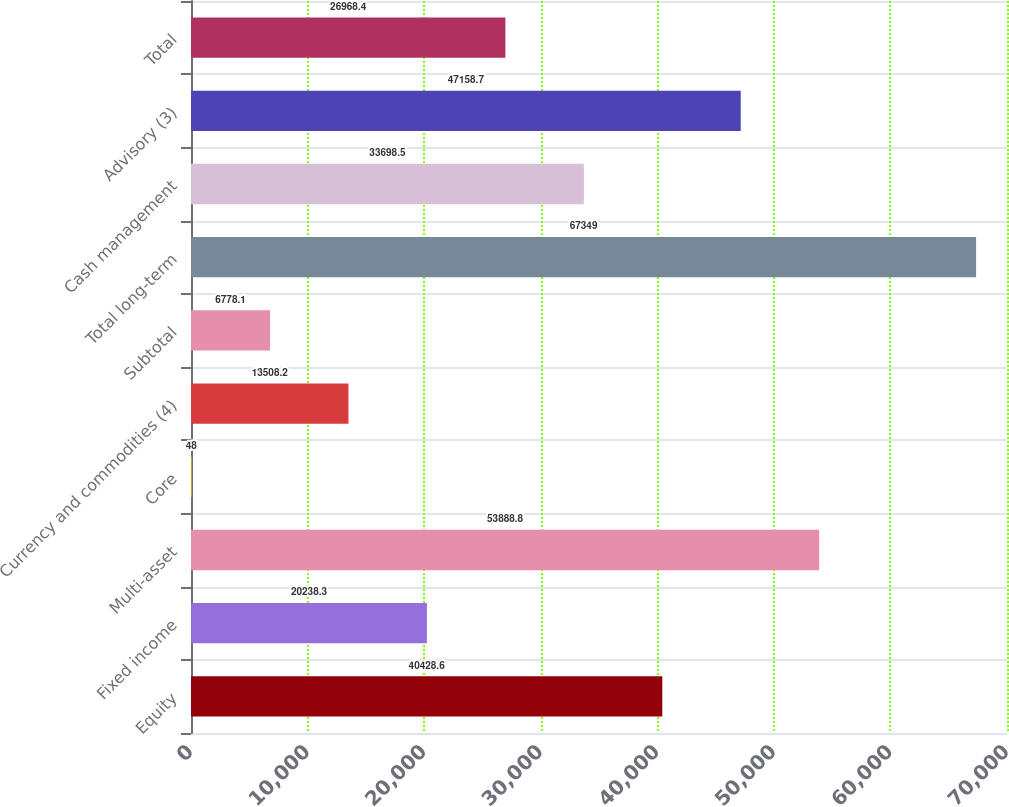Convert chart. <chart><loc_0><loc_0><loc_500><loc_500><bar_chart><fcel>Equity<fcel>Fixed income<fcel>Multi-asset<fcel>Core<fcel>Currency and commodities (4)<fcel>Subtotal<fcel>Total long-term<fcel>Cash management<fcel>Advisory (3)<fcel>Total<nl><fcel>40428.6<fcel>20238.3<fcel>53888.8<fcel>48<fcel>13508.2<fcel>6778.1<fcel>67349<fcel>33698.5<fcel>47158.7<fcel>26968.4<nl></chart> 